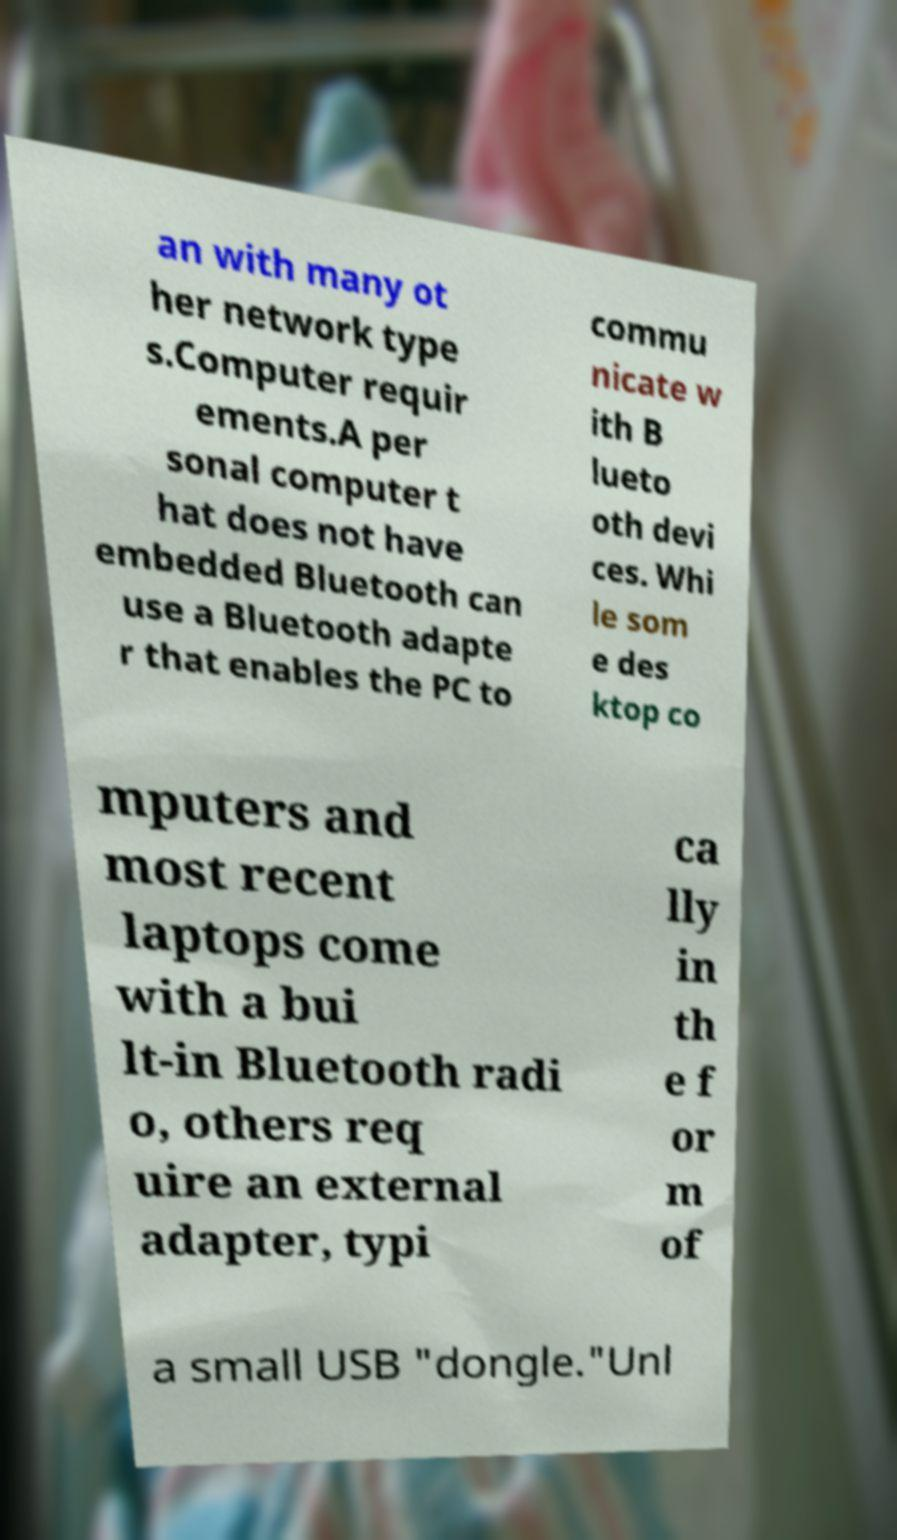Could you assist in decoding the text presented in this image and type it out clearly? an with many ot her network type s.Computer requir ements.A per sonal computer t hat does not have embedded Bluetooth can use a Bluetooth adapte r that enables the PC to commu nicate w ith B lueto oth devi ces. Whi le som e des ktop co mputers and most recent laptops come with a bui lt-in Bluetooth radi o, others req uire an external adapter, typi ca lly in th e f or m of a small USB "dongle."Unl 